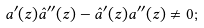<formula> <loc_0><loc_0><loc_500><loc_500>a ^ { \prime } ( z ) \hat { a } ^ { \prime \prime } ( z ) - \hat { a } ^ { \prime } ( z ) a ^ { \prime \prime } ( z ) \neq 0 ;</formula> 